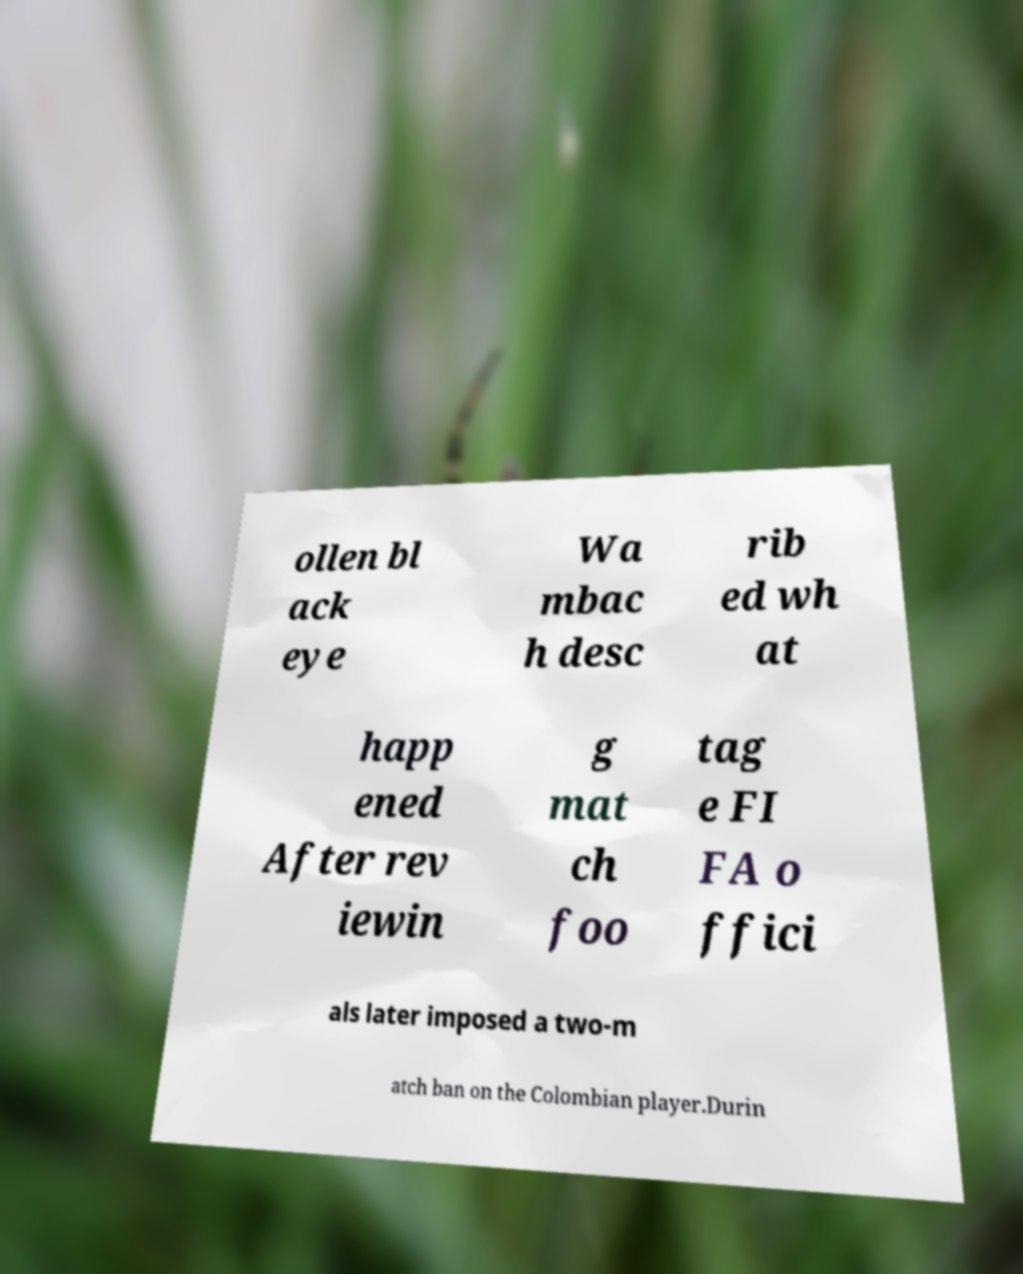Could you extract and type out the text from this image? ollen bl ack eye Wa mbac h desc rib ed wh at happ ened After rev iewin g mat ch foo tag e FI FA o ffici als later imposed a two-m atch ban on the Colombian player.Durin 